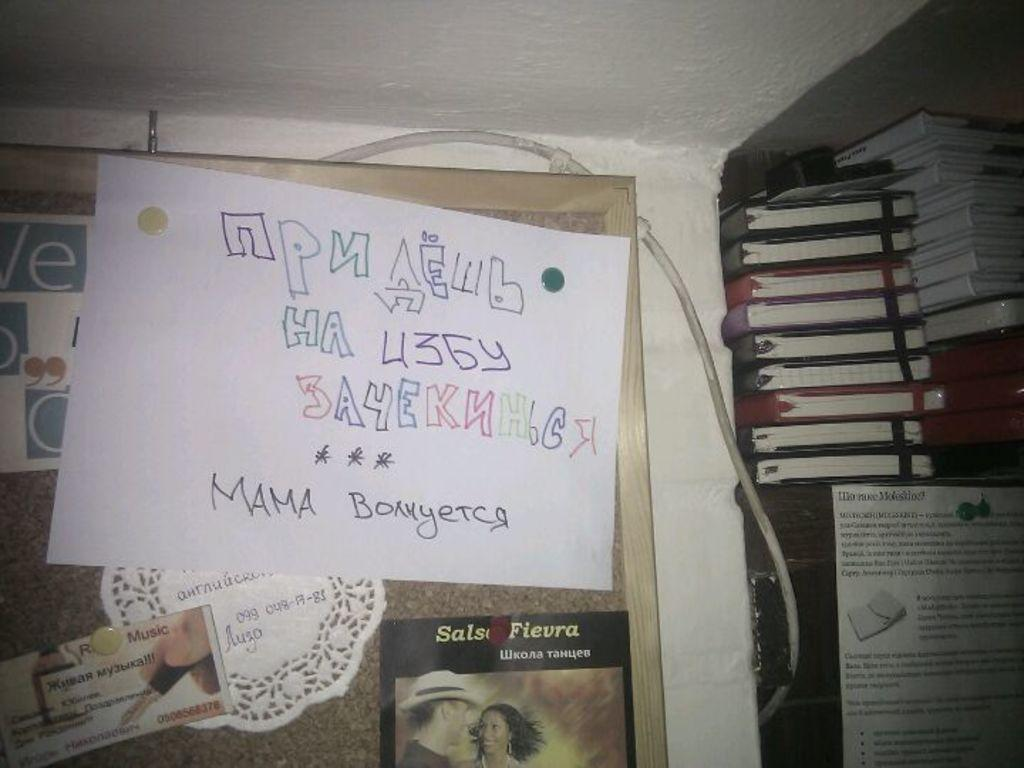What is located in the center of the image? There are posters in the center of the image. Where are the books in the image? The books are on a desk on the right side of the image. What type of paste is being used by the father in the image? There is no father present in the image, and therefore no one is using any paste. How does the earthquake affect the posters in the image? There is no earthquake present in the image, so the posters are not affected by any tremors. 